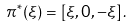<formula> <loc_0><loc_0><loc_500><loc_500>\pi ^ { * } ( \xi ) = \left [ \xi , 0 , - \xi \right ] .</formula> 